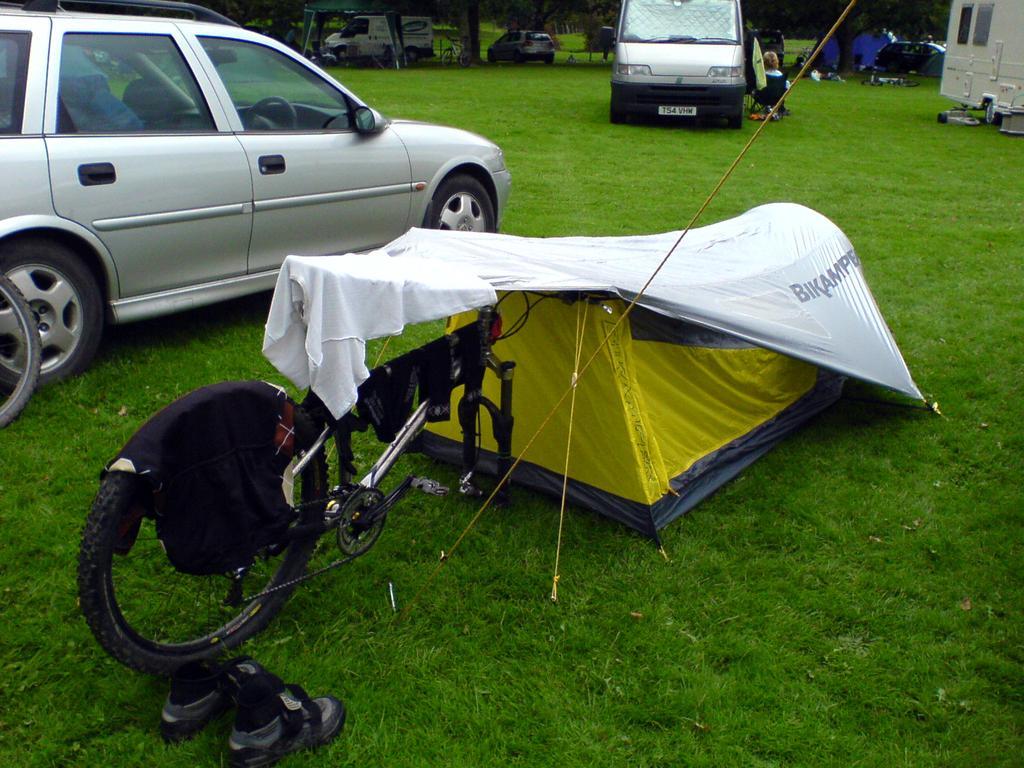In one or two sentences, can you explain what this image depicts? In this image we can see bicycle, tent. There are cars, trees. At the bottom of the image there is grass. There is a pair of shoes to the left side of the image. 